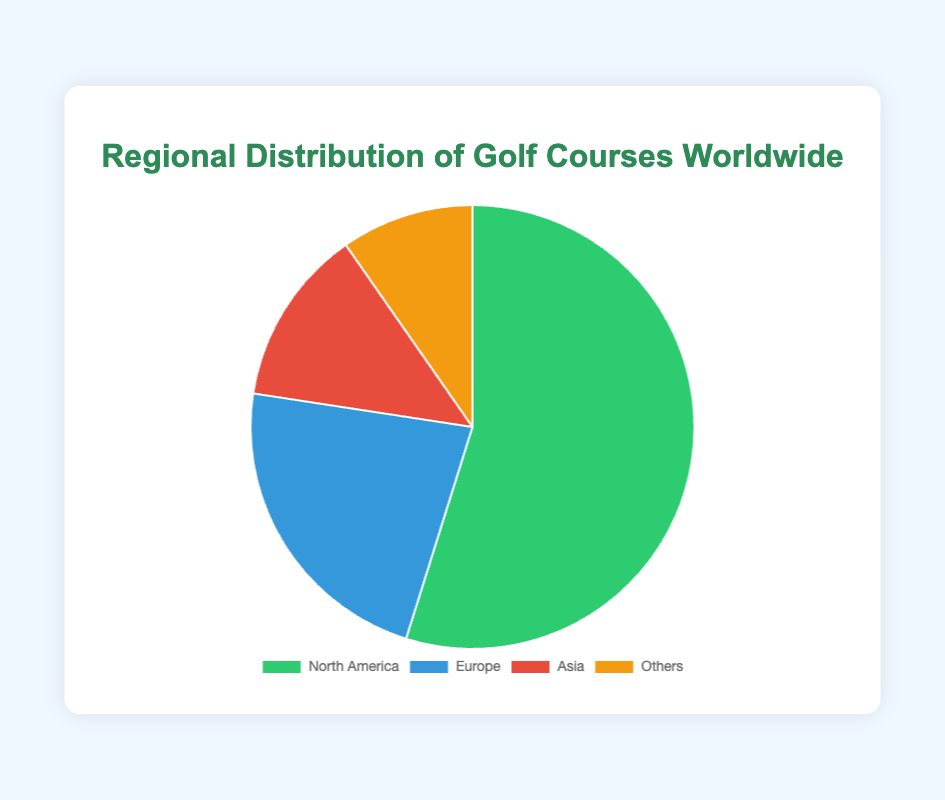What percentage of the total golf courses are in North America? North America has 17,000 golf courses out of a total of 31,000 golf courses. To find the percentage: (17,000 / 31,000) × 100 ≈ 54.84%
Answer: 54.84% Which region has the least number of golf courses? Looking at the dataset, the "Others" category has the lowest number of golf courses, which is 3,000.
Answer: Others How many more golf courses does Europe have compared to Asia? Europe has 7,000 golf courses, and Asia has 4,000 golf courses. The difference is 7,000 - 4,000 = 3,000.
Answer: 3,000 What is the combined total of golf courses in Europe and Asia? Adding the golf courses in Europe and Asia: 7,000 + 4,000 = 11,000.
Answer: 11,000 Which region has the largest share of golf courses and by what margin compared to the second-largest region? North America has the largest share with 17,000 golf courses. The second-largest is Europe with 7,000. The margin is 17,000 - 7,000 = 10,000.
Answer: 10,000 What proportion of the total golf courses are located outside of North America (i.e., in Europe, Asia, and Others combined)? Europe, Asia, and Others combined have 7,000 + 4,000 + 3,000 = 14,000. The total number of golf courses is 31,000. The proportion is 14,000 / 31,000 ≈ 45.16%.
Answer: 45.16% Identify the color used for the region with the fewest golf courses. In the pie chart, the "Others" region is represented with the color orange.
Answer: Orange How does the number of golf courses in Asia compare to the combined total of Europe and Others? Europe and Others combined have 7,000 + 3,000 = 10,000 golf courses. Asia has 4,000 golf courses. 10,000 is larger than 4,000.
Answer: Less than What percentage of the golf courses are located in both Europe and Others together? Europe and Others together have 7,000 + 3,000 = 10,000 golf courses. The total number of golf courses is 31,000. The percentage is (10,000 / 31,000) × 100 ≈ 32.26%.
Answer: 32.26% 